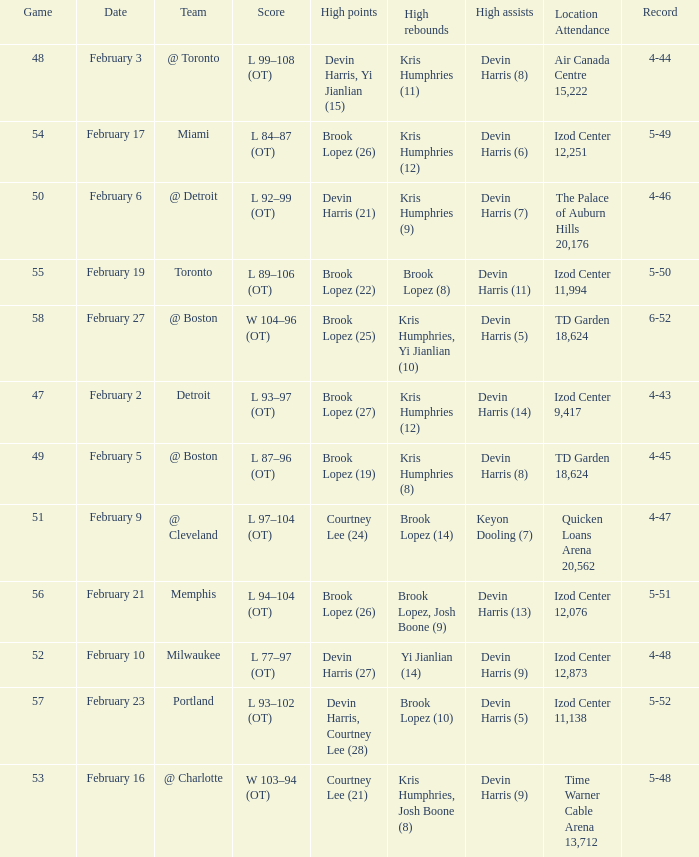What team was the game on February 27 played against? @ Boston. 